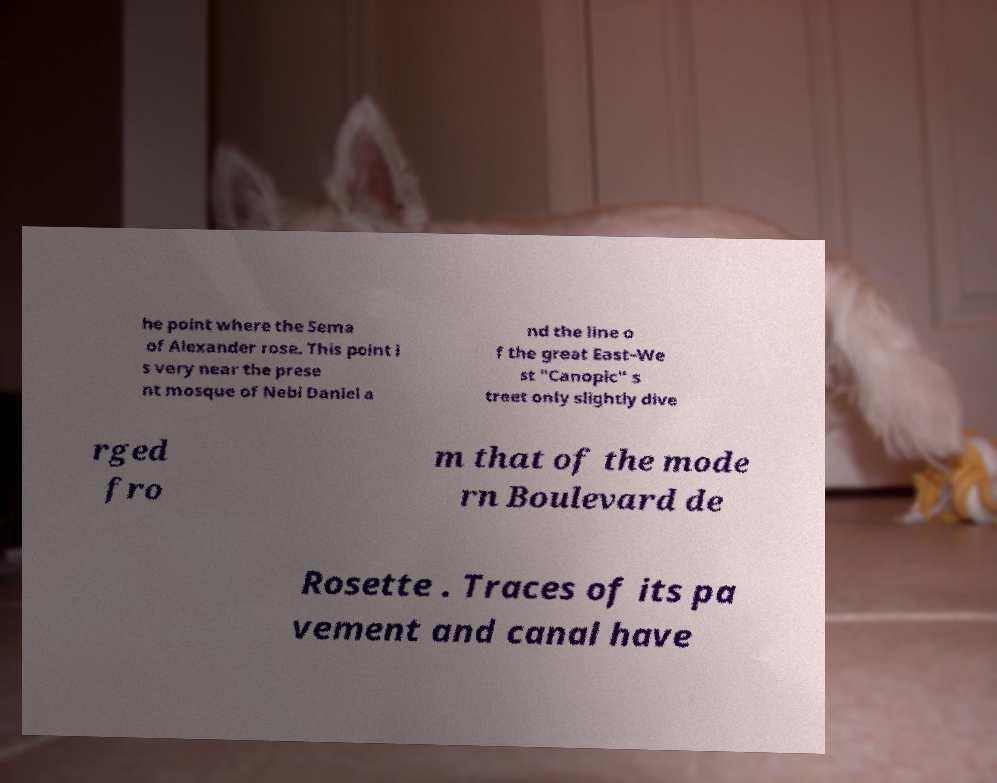I need the written content from this picture converted into text. Can you do that? he point where the Sema of Alexander rose. This point i s very near the prese nt mosque of Nebi Daniel a nd the line o f the great East–We st "Canopic" s treet only slightly dive rged fro m that of the mode rn Boulevard de Rosette . Traces of its pa vement and canal have 